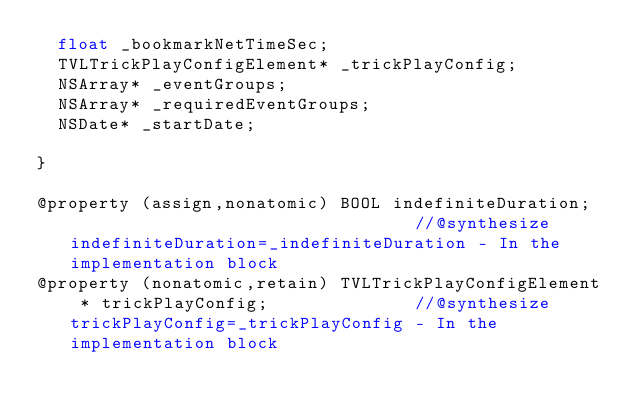Convert code to text. <code><loc_0><loc_0><loc_500><loc_500><_C_>	float _bookmarkNetTimeSec;
	TVLTrickPlayConfigElement* _trickPlayConfig;
	NSArray* _eventGroups;
	NSArray* _requiredEventGroups;
	NSDate* _startDate;

}

@property (assign,nonatomic) BOOL indefiniteDuration;                                  //@synthesize indefiniteDuration=_indefiniteDuration - In the implementation block
@property (nonatomic,retain) TVLTrickPlayConfigElement * trickPlayConfig;              //@synthesize trickPlayConfig=_trickPlayConfig - In the implementation block</code> 